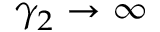<formula> <loc_0><loc_0><loc_500><loc_500>\gamma _ { 2 } \to \infty</formula> 